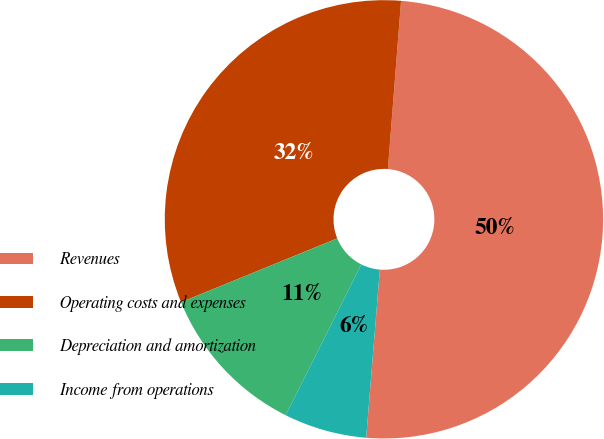Convert chart to OTSL. <chart><loc_0><loc_0><loc_500><loc_500><pie_chart><fcel>Revenues<fcel>Operating costs and expenses<fcel>Depreciation and amortization<fcel>Income from operations<nl><fcel>50.05%<fcel>32.42%<fcel>11.43%<fcel>6.11%<nl></chart> 